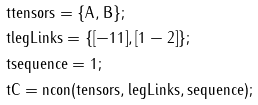<formula> <loc_0><loc_0><loc_500><loc_500>& \tt t { t e n s o r s = \{ A , B \} ; } \\ & \tt t { l e g L i n k s = \{ [ - 1 1 ] , [ 1 - 2 ] \} ; } \\ & \tt t { s e q u e n c e = 1 ; } \\ & \tt t { C = n c o n ( t e n s o r s , l e g L i n k s , s e q u e n c e ) ; }</formula> 